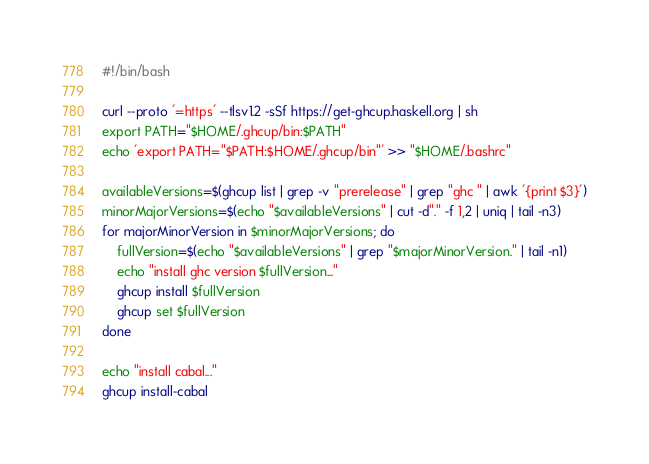<code> <loc_0><loc_0><loc_500><loc_500><_Bash_>#!/bin/bash

curl --proto '=https' --tlsv1.2 -sSf https://get-ghcup.haskell.org | sh
export PATH="$HOME/.ghcup/bin:$PATH"
echo 'export PATH="$PATH:$HOME/.ghcup/bin"' >> "$HOME/.bashrc"

availableVersions=$(ghcup list | grep -v "prerelease" | grep "ghc " | awk '{print $3}')
minorMajorVersions=$(echo "$availableVersions" | cut -d"." -f 1,2 | uniq | tail -n3)
for majorMinorVersion in $minorMajorVersions; do
    fullVersion=$(echo "$availableVersions" | grep "$majorMinorVersion." | tail -n1)
    echo "install ghc version $fullVersion..."
    ghcup install $fullVersion
    ghcup set $fullVersion
done

echo "install cabal..."
ghcup install-cabal
</code> 